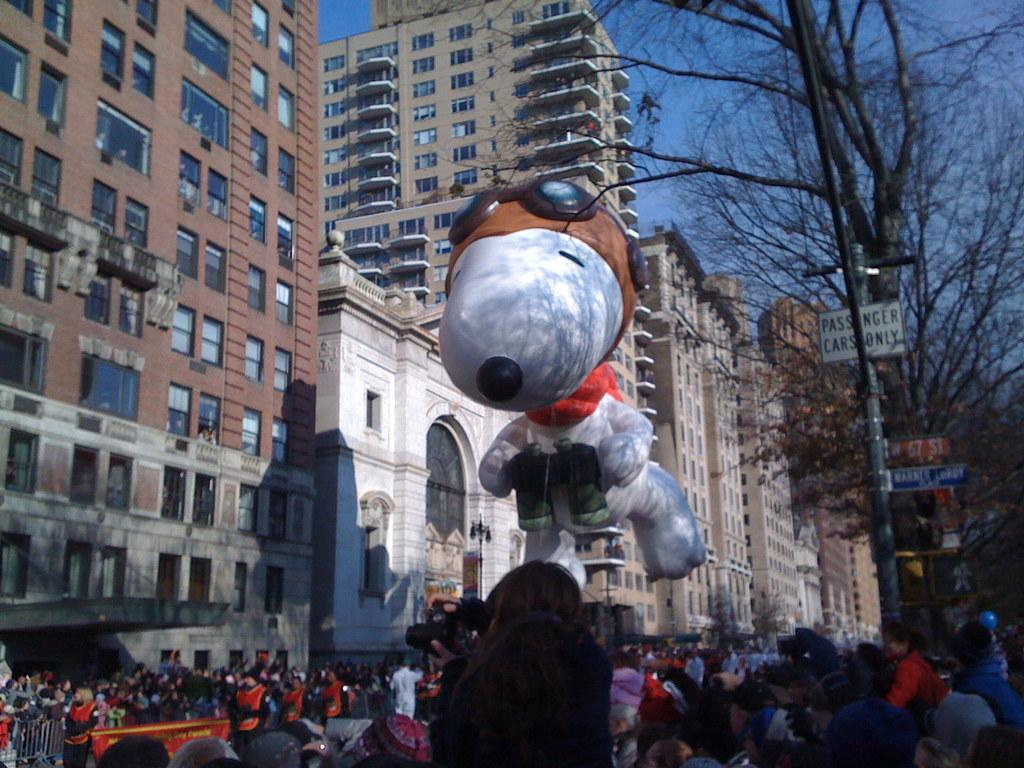How many people are in the image? There is a group of people in the image, but the exact number cannot be determined from the provided facts. What is located in the middle of the image? There is an inflatable toy in the middle of the image. What can be seen in the background of the image? There are sign boards, trees, buildings, and poles in the background of the image. What type of picture is hanging on the thumb of the person in the image? There is no mention of a picture or a thumb in the provided facts, so this question cannot be answered. 